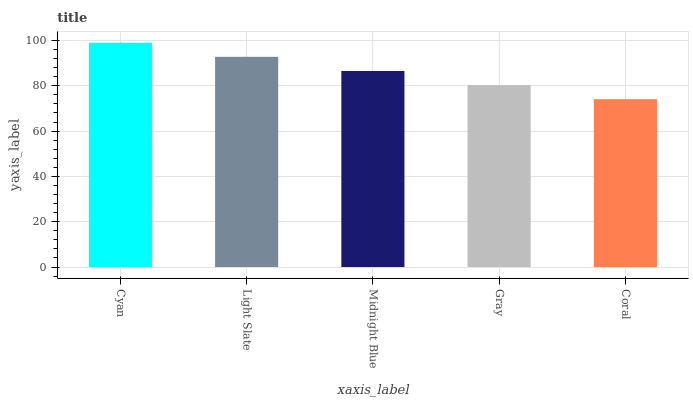Is Coral the minimum?
Answer yes or no. Yes. Is Cyan the maximum?
Answer yes or no. Yes. Is Light Slate the minimum?
Answer yes or no. No. Is Light Slate the maximum?
Answer yes or no. No. Is Cyan greater than Light Slate?
Answer yes or no. Yes. Is Light Slate less than Cyan?
Answer yes or no. Yes. Is Light Slate greater than Cyan?
Answer yes or no. No. Is Cyan less than Light Slate?
Answer yes or no. No. Is Midnight Blue the high median?
Answer yes or no. Yes. Is Midnight Blue the low median?
Answer yes or no. Yes. Is Coral the high median?
Answer yes or no. No. Is Gray the low median?
Answer yes or no. No. 